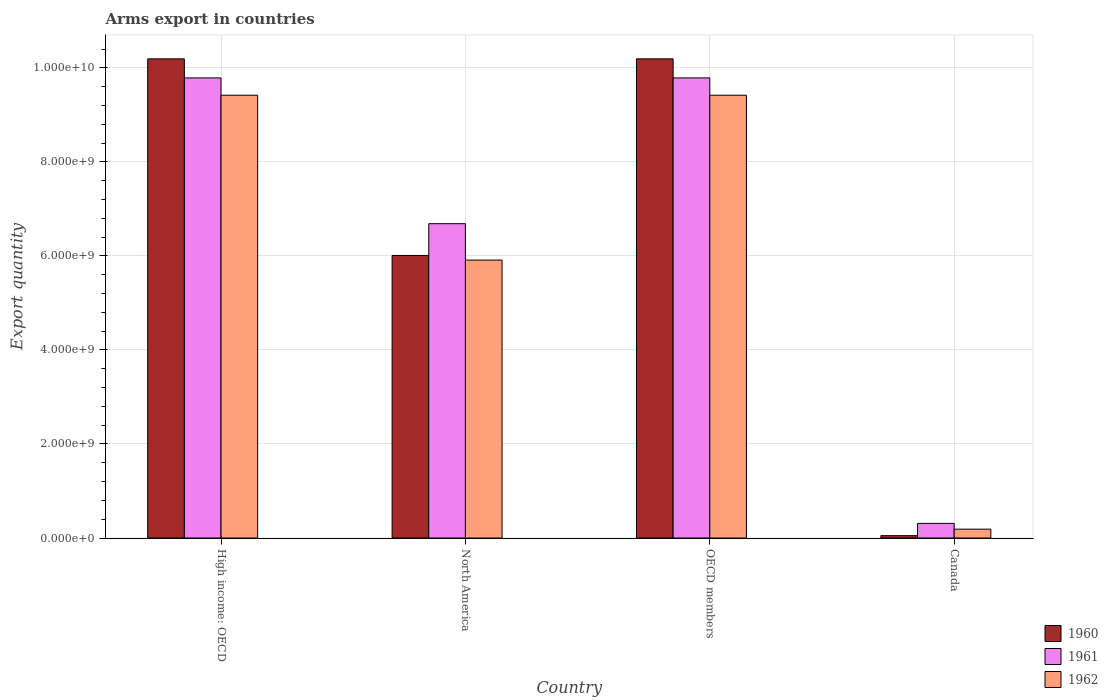How many different coloured bars are there?
Offer a terse response. 3. Are the number of bars per tick equal to the number of legend labels?
Provide a succinct answer. Yes. Are the number of bars on each tick of the X-axis equal?
Provide a succinct answer. Yes. How many bars are there on the 4th tick from the right?
Your answer should be very brief. 3. What is the label of the 1st group of bars from the left?
Ensure brevity in your answer.  High income: OECD. What is the total arms export in 1962 in Canada?
Your response must be concise. 1.88e+08. Across all countries, what is the maximum total arms export in 1961?
Offer a terse response. 9.79e+09. Across all countries, what is the minimum total arms export in 1962?
Your response must be concise. 1.88e+08. In which country was the total arms export in 1961 maximum?
Keep it short and to the point. High income: OECD. What is the total total arms export in 1960 in the graph?
Your answer should be compact. 2.64e+1. What is the difference between the total arms export in 1960 in Canada and that in North America?
Give a very brief answer. -5.96e+09. What is the difference between the total arms export in 1961 in High income: OECD and the total arms export in 1962 in OECD members?
Give a very brief answer. 3.68e+08. What is the average total arms export in 1962 per country?
Keep it short and to the point. 6.24e+09. What is the difference between the total arms export of/in 1960 and total arms export of/in 1962 in North America?
Your answer should be very brief. 9.80e+07. What is the ratio of the total arms export in 1960 in Canada to that in High income: OECD?
Keep it short and to the point. 0. What is the difference between the highest and the second highest total arms export in 1962?
Keep it short and to the point. 3.51e+09. What is the difference between the highest and the lowest total arms export in 1962?
Your answer should be very brief. 9.23e+09. In how many countries, is the total arms export in 1962 greater than the average total arms export in 1962 taken over all countries?
Make the answer very short. 2. Is the sum of the total arms export in 1960 in North America and OECD members greater than the maximum total arms export in 1962 across all countries?
Give a very brief answer. Yes. What does the 1st bar from the left in Canada represents?
Your answer should be compact. 1960. What does the 3rd bar from the right in North America represents?
Make the answer very short. 1960. Is it the case that in every country, the sum of the total arms export in 1961 and total arms export in 1962 is greater than the total arms export in 1960?
Your answer should be compact. Yes. How many bars are there?
Your answer should be very brief. 12. How many countries are there in the graph?
Ensure brevity in your answer.  4. Are the values on the major ticks of Y-axis written in scientific E-notation?
Provide a succinct answer. Yes. How are the legend labels stacked?
Your answer should be compact. Vertical. What is the title of the graph?
Your answer should be very brief. Arms export in countries. What is the label or title of the Y-axis?
Make the answer very short. Export quantity. What is the Export quantity of 1960 in High income: OECD?
Offer a terse response. 1.02e+1. What is the Export quantity in 1961 in High income: OECD?
Offer a very short reply. 9.79e+09. What is the Export quantity of 1962 in High income: OECD?
Your response must be concise. 9.42e+09. What is the Export quantity in 1960 in North America?
Keep it short and to the point. 6.01e+09. What is the Export quantity in 1961 in North America?
Provide a succinct answer. 6.69e+09. What is the Export quantity in 1962 in North America?
Give a very brief answer. 5.91e+09. What is the Export quantity in 1960 in OECD members?
Offer a very short reply. 1.02e+1. What is the Export quantity of 1961 in OECD members?
Give a very brief answer. 9.79e+09. What is the Export quantity of 1962 in OECD members?
Provide a short and direct response. 9.42e+09. What is the Export quantity of 1961 in Canada?
Ensure brevity in your answer.  3.11e+08. What is the Export quantity in 1962 in Canada?
Offer a terse response. 1.88e+08. Across all countries, what is the maximum Export quantity of 1960?
Your answer should be compact. 1.02e+1. Across all countries, what is the maximum Export quantity of 1961?
Your response must be concise. 9.79e+09. Across all countries, what is the maximum Export quantity in 1962?
Your response must be concise. 9.42e+09. Across all countries, what is the minimum Export quantity of 1961?
Your answer should be compact. 3.11e+08. Across all countries, what is the minimum Export quantity in 1962?
Offer a very short reply. 1.88e+08. What is the total Export quantity of 1960 in the graph?
Provide a succinct answer. 2.64e+1. What is the total Export quantity of 1961 in the graph?
Your answer should be compact. 2.66e+1. What is the total Export quantity of 1962 in the graph?
Offer a terse response. 2.49e+1. What is the difference between the Export quantity in 1960 in High income: OECD and that in North America?
Your answer should be compact. 4.18e+09. What is the difference between the Export quantity in 1961 in High income: OECD and that in North America?
Your answer should be very brief. 3.10e+09. What is the difference between the Export quantity of 1962 in High income: OECD and that in North America?
Offer a terse response. 3.51e+09. What is the difference between the Export quantity in 1962 in High income: OECD and that in OECD members?
Give a very brief answer. 0. What is the difference between the Export quantity of 1960 in High income: OECD and that in Canada?
Your answer should be very brief. 1.01e+1. What is the difference between the Export quantity in 1961 in High income: OECD and that in Canada?
Provide a short and direct response. 9.48e+09. What is the difference between the Export quantity in 1962 in High income: OECD and that in Canada?
Offer a terse response. 9.23e+09. What is the difference between the Export quantity in 1960 in North America and that in OECD members?
Ensure brevity in your answer.  -4.18e+09. What is the difference between the Export quantity in 1961 in North America and that in OECD members?
Provide a short and direct response. -3.10e+09. What is the difference between the Export quantity in 1962 in North America and that in OECD members?
Offer a very short reply. -3.51e+09. What is the difference between the Export quantity in 1960 in North America and that in Canada?
Offer a terse response. 5.96e+09. What is the difference between the Export quantity of 1961 in North America and that in Canada?
Offer a terse response. 6.38e+09. What is the difference between the Export quantity in 1962 in North America and that in Canada?
Keep it short and to the point. 5.72e+09. What is the difference between the Export quantity in 1960 in OECD members and that in Canada?
Make the answer very short. 1.01e+1. What is the difference between the Export quantity in 1961 in OECD members and that in Canada?
Ensure brevity in your answer.  9.48e+09. What is the difference between the Export quantity of 1962 in OECD members and that in Canada?
Offer a very short reply. 9.23e+09. What is the difference between the Export quantity in 1960 in High income: OECD and the Export quantity in 1961 in North America?
Your answer should be compact. 3.51e+09. What is the difference between the Export quantity of 1960 in High income: OECD and the Export quantity of 1962 in North America?
Give a very brief answer. 4.28e+09. What is the difference between the Export quantity in 1961 in High income: OECD and the Export quantity in 1962 in North America?
Your response must be concise. 3.88e+09. What is the difference between the Export quantity of 1960 in High income: OECD and the Export quantity of 1961 in OECD members?
Provide a short and direct response. 4.06e+08. What is the difference between the Export quantity in 1960 in High income: OECD and the Export quantity in 1962 in OECD members?
Provide a short and direct response. 7.74e+08. What is the difference between the Export quantity in 1961 in High income: OECD and the Export quantity in 1962 in OECD members?
Provide a succinct answer. 3.68e+08. What is the difference between the Export quantity in 1960 in High income: OECD and the Export quantity in 1961 in Canada?
Make the answer very short. 9.88e+09. What is the difference between the Export quantity of 1960 in High income: OECD and the Export quantity of 1962 in Canada?
Provide a short and direct response. 1.00e+1. What is the difference between the Export quantity of 1961 in High income: OECD and the Export quantity of 1962 in Canada?
Offer a very short reply. 9.60e+09. What is the difference between the Export quantity of 1960 in North America and the Export quantity of 1961 in OECD members?
Make the answer very short. -3.78e+09. What is the difference between the Export quantity of 1960 in North America and the Export quantity of 1962 in OECD members?
Provide a short and direct response. -3.41e+09. What is the difference between the Export quantity in 1961 in North America and the Export quantity in 1962 in OECD members?
Provide a short and direct response. -2.73e+09. What is the difference between the Export quantity of 1960 in North America and the Export quantity of 1961 in Canada?
Your response must be concise. 5.70e+09. What is the difference between the Export quantity in 1960 in North America and the Export quantity in 1962 in Canada?
Ensure brevity in your answer.  5.82e+09. What is the difference between the Export quantity in 1961 in North America and the Export quantity in 1962 in Canada?
Offer a terse response. 6.50e+09. What is the difference between the Export quantity in 1960 in OECD members and the Export quantity in 1961 in Canada?
Ensure brevity in your answer.  9.88e+09. What is the difference between the Export quantity in 1960 in OECD members and the Export quantity in 1962 in Canada?
Offer a very short reply. 1.00e+1. What is the difference between the Export quantity in 1961 in OECD members and the Export quantity in 1962 in Canada?
Your answer should be very brief. 9.60e+09. What is the average Export quantity in 1960 per country?
Your answer should be very brief. 6.61e+09. What is the average Export quantity in 1961 per country?
Keep it short and to the point. 6.64e+09. What is the average Export quantity in 1962 per country?
Your answer should be very brief. 6.24e+09. What is the difference between the Export quantity of 1960 and Export quantity of 1961 in High income: OECD?
Your answer should be very brief. 4.06e+08. What is the difference between the Export quantity of 1960 and Export quantity of 1962 in High income: OECD?
Offer a terse response. 7.74e+08. What is the difference between the Export quantity of 1961 and Export quantity of 1962 in High income: OECD?
Make the answer very short. 3.68e+08. What is the difference between the Export quantity in 1960 and Export quantity in 1961 in North America?
Keep it short and to the point. -6.76e+08. What is the difference between the Export quantity of 1960 and Export quantity of 1962 in North America?
Offer a very short reply. 9.80e+07. What is the difference between the Export quantity of 1961 and Export quantity of 1962 in North America?
Keep it short and to the point. 7.74e+08. What is the difference between the Export quantity of 1960 and Export quantity of 1961 in OECD members?
Offer a very short reply. 4.06e+08. What is the difference between the Export quantity of 1960 and Export quantity of 1962 in OECD members?
Provide a short and direct response. 7.74e+08. What is the difference between the Export quantity in 1961 and Export quantity in 1962 in OECD members?
Offer a very short reply. 3.68e+08. What is the difference between the Export quantity in 1960 and Export quantity in 1961 in Canada?
Ensure brevity in your answer.  -2.61e+08. What is the difference between the Export quantity in 1960 and Export quantity in 1962 in Canada?
Ensure brevity in your answer.  -1.38e+08. What is the difference between the Export quantity in 1961 and Export quantity in 1962 in Canada?
Provide a succinct answer. 1.23e+08. What is the ratio of the Export quantity of 1960 in High income: OECD to that in North America?
Keep it short and to the point. 1.7. What is the ratio of the Export quantity of 1961 in High income: OECD to that in North America?
Keep it short and to the point. 1.46. What is the ratio of the Export quantity of 1962 in High income: OECD to that in North America?
Provide a short and direct response. 1.59. What is the ratio of the Export quantity in 1960 in High income: OECD to that in OECD members?
Provide a succinct answer. 1. What is the ratio of the Export quantity in 1961 in High income: OECD to that in OECD members?
Your answer should be compact. 1. What is the ratio of the Export quantity of 1960 in High income: OECD to that in Canada?
Your answer should be very brief. 203.88. What is the ratio of the Export quantity in 1961 in High income: OECD to that in Canada?
Offer a terse response. 31.47. What is the ratio of the Export quantity of 1962 in High income: OECD to that in Canada?
Your answer should be very brief. 50.11. What is the ratio of the Export quantity of 1960 in North America to that in OECD members?
Offer a very short reply. 0.59. What is the ratio of the Export quantity of 1961 in North America to that in OECD members?
Ensure brevity in your answer.  0.68. What is the ratio of the Export quantity in 1962 in North America to that in OECD members?
Your response must be concise. 0.63. What is the ratio of the Export quantity of 1960 in North America to that in Canada?
Ensure brevity in your answer.  120.22. What is the ratio of the Export quantity in 1961 in North America to that in Canada?
Offer a very short reply. 21.5. What is the ratio of the Export quantity in 1962 in North America to that in Canada?
Make the answer very short. 31.45. What is the ratio of the Export quantity of 1960 in OECD members to that in Canada?
Ensure brevity in your answer.  203.88. What is the ratio of the Export quantity of 1961 in OECD members to that in Canada?
Offer a terse response. 31.47. What is the ratio of the Export quantity of 1962 in OECD members to that in Canada?
Provide a succinct answer. 50.11. What is the difference between the highest and the second highest Export quantity of 1961?
Provide a succinct answer. 0. What is the difference between the highest and the lowest Export quantity in 1960?
Your response must be concise. 1.01e+1. What is the difference between the highest and the lowest Export quantity of 1961?
Keep it short and to the point. 9.48e+09. What is the difference between the highest and the lowest Export quantity of 1962?
Your response must be concise. 9.23e+09. 